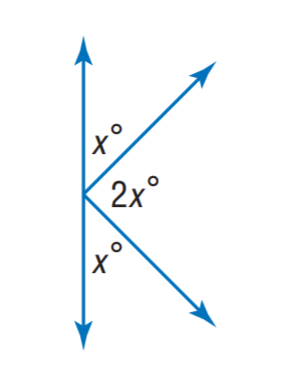Answer the mathemtical geometry problem and directly provide the correct option letter.
Question: Find x.
Choices: A: 30 B: 45 C: 60 D: 75 B 